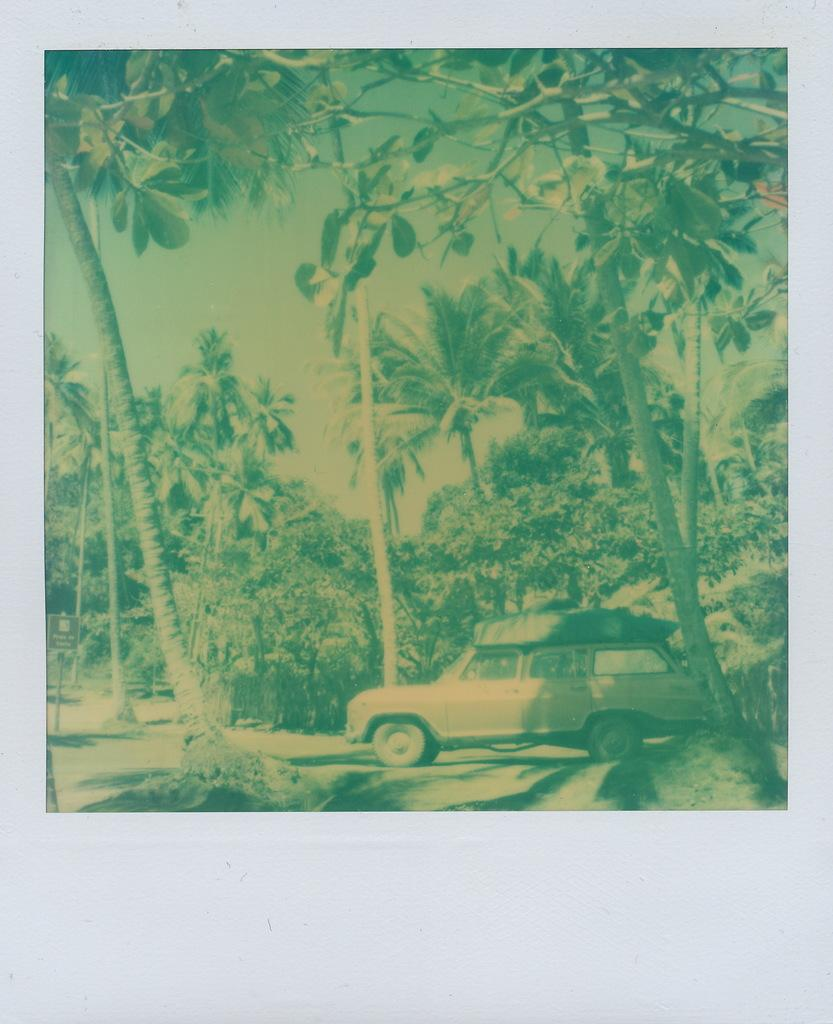What is hanging on the wall in the image? There is a photo on the wall in the image. What elements can be seen in the photo? The photo contains trees, plants, grass, a sign board, a car, and the sky. Where is the cat sitting in the image? There is no cat present in the image. What type of cream is being used to paint the car in the image? There is no indication of the car being painted or any cream being used in the image. 